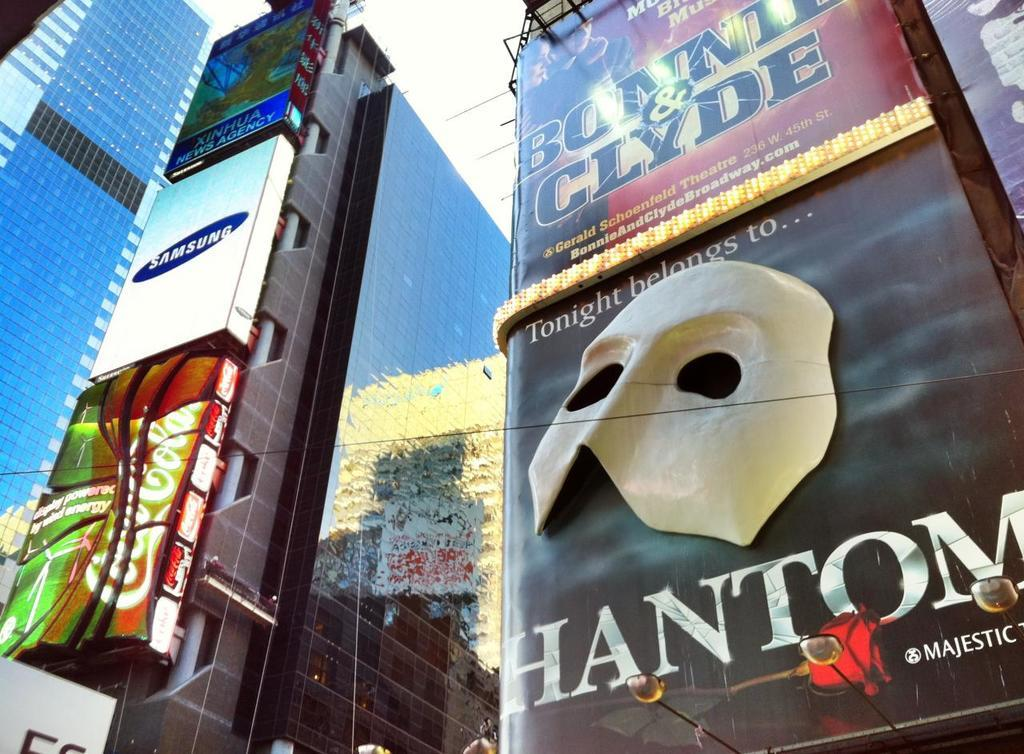What type of structures can be seen in the image? There are buildings in the image. What is featured on the walls of the buildings? There are advertisements on the walls of the buildings. What can be seen in the background of the image? The sky is visible in the background of the image. How many times does the cap appear in the image? There is no cap present in the image. What type of land is visible in the image? The image does not show any land; it features buildings and advertisements on their walls, with the sky visible in the background. 